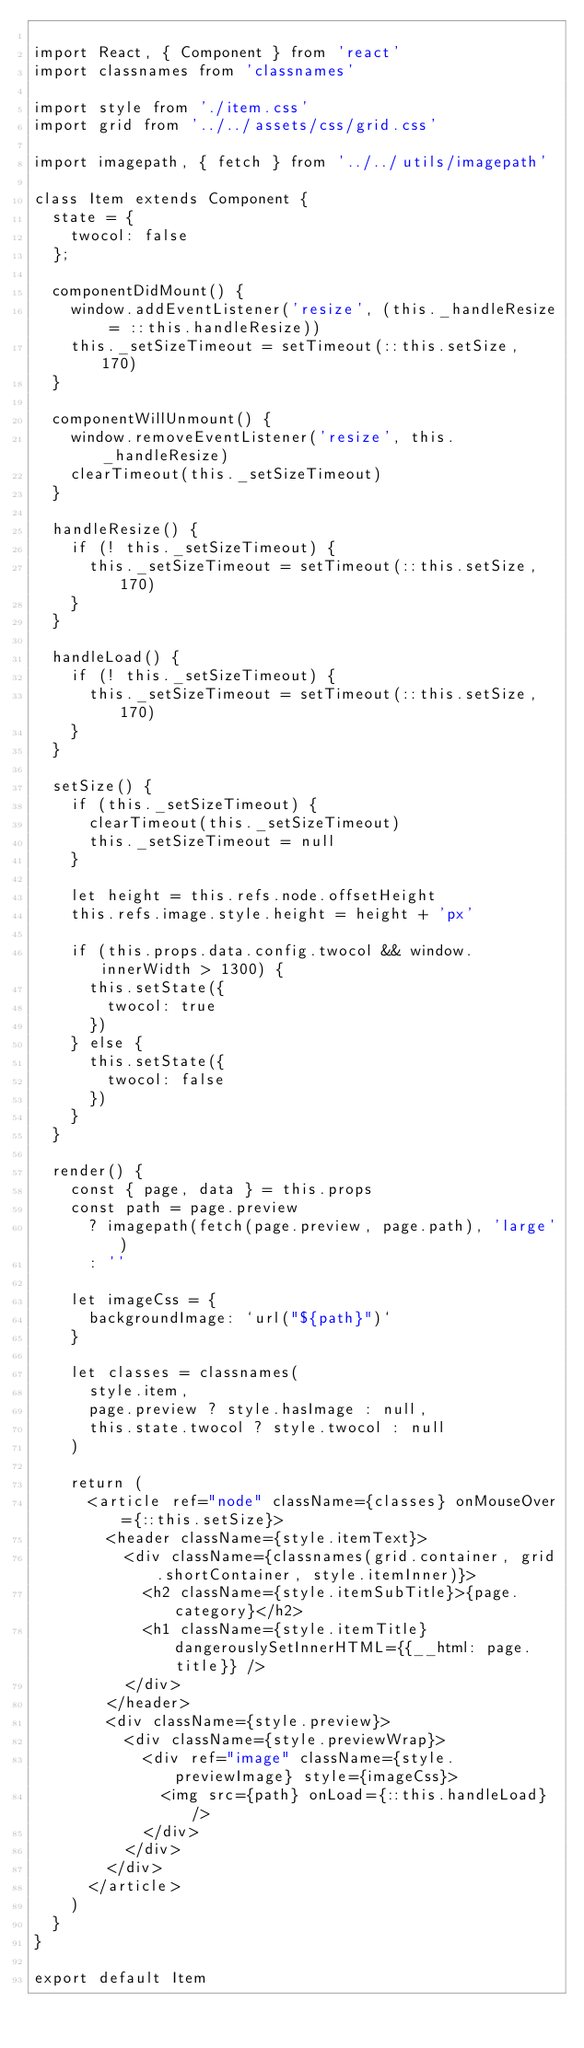<code> <loc_0><loc_0><loc_500><loc_500><_JavaScript_>
import React, { Component } from 'react'
import classnames from 'classnames'

import style from './item.css'
import grid from '../../assets/css/grid.css'

import imagepath, { fetch } from '../../utils/imagepath'

class Item extends Component {
  state = {
    twocol: false
  };

  componentDidMount() {
    window.addEventListener('resize', (this._handleResize = ::this.handleResize))
    this._setSizeTimeout = setTimeout(::this.setSize, 170)
  }

  componentWillUnmount() {
    window.removeEventListener('resize', this._handleResize)
    clearTimeout(this._setSizeTimeout)
  }

  handleResize() {
    if (! this._setSizeTimeout) {
      this._setSizeTimeout = setTimeout(::this.setSize, 170)
    }
  }

  handleLoad() {
    if (! this._setSizeTimeout) {
      this._setSizeTimeout = setTimeout(::this.setSize, 170)
    }
  }

  setSize() {
    if (this._setSizeTimeout) {
      clearTimeout(this._setSizeTimeout)
      this._setSizeTimeout = null
    }

    let height = this.refs.node.offsetHeight
    this.refs.image.style.height = height + 'px'

    if (this.props.data.config.twocol && window.innerWidth > 1300) {
      this.setState({
        twocol: true
      })
    } else {
      this.setState({
        twocol: false
      })
    }
  }

  render() {
    const { page, data } = this.props
    const path = page.preview
      ? imagepath(fetch(page.preview, page.path), 'large')
      : ''

    let imageCss = {
      backgroundImage: `url("${path}")`
    }

    let classes = classnames(
      style.item,
      page.preview ? style.hasImage : null,
      this.state.twocol ? style.twocol : null
    )

    return (
      <article ref="node" className={classes} onMouseOver={::this.setSize}>
        <header className={style.itemText}>
          <div className={classnames(grid.container, grid.shortContainer, style.itemInner)}>
            <h2 className={style.itemSubTitle}>{page.category}</h2>
            <h1 className={style.itemTitle} dangerouslySetInnerHTML={{__html: page.title}} />
          </div>
        </header>
        <div className={style.preview}>
          <div className={style.previewWrap}>
            <div ref="image" className={style.previewImage} style={imageCss}>
              <img src={path} onLoad={::this.handleLoad} />
            </div>
          </div>
        </div>
      </article>
    )
  }
}

export default Item
</code> 